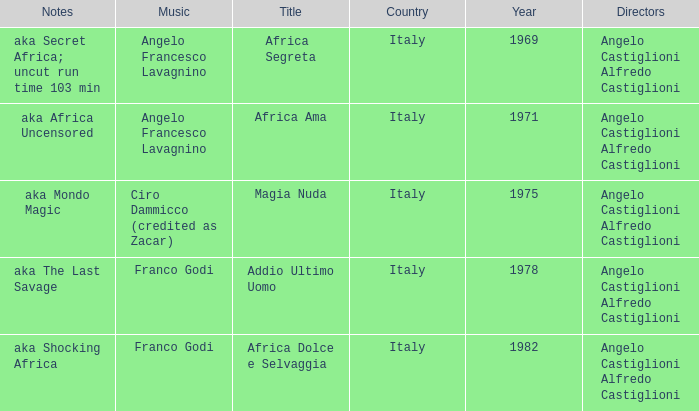Which music has the notes of AKA Africa Uncensored? Angelo Francesco Lavagnino. 